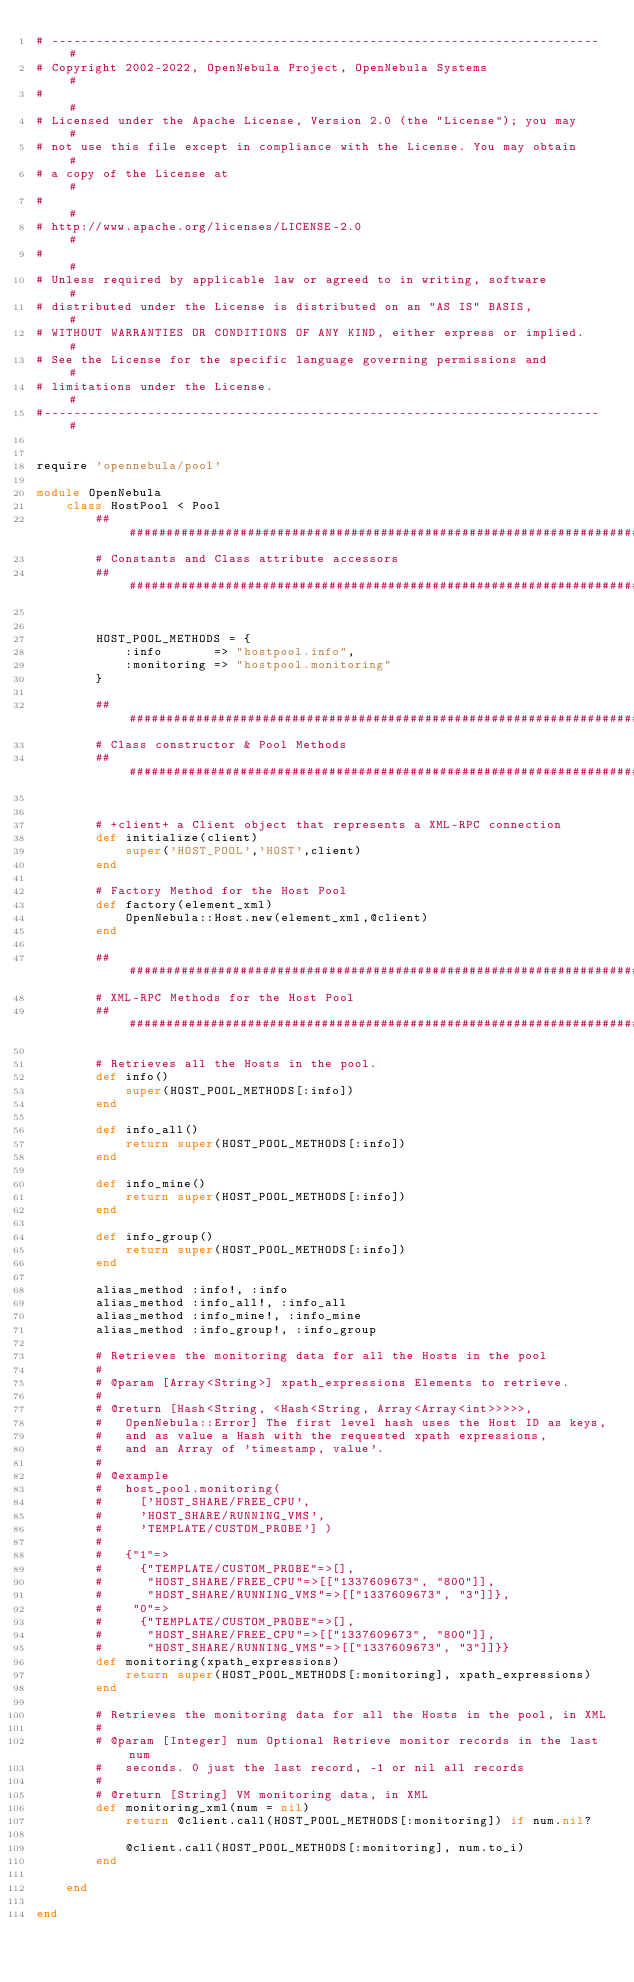Convert code to text. <code><loc_0><loc_0><loc_500><loc_500><_Ruby_># -------------------------------------------------------------------------- #
# Copyright 2002-2022, OpenNebula Project, OpenNebula Systems                #
#                                                                            #
# Licensed under the Apache License, Version 2.0 (the "License"); you may    #
# not use this file except in compliance with the License. You may obtain    #
# a copy of the License at                                                   #
#                                                                            #
# http://www.apache.org/licenses/LICENSE-2.0                                 #
#                                                                            #
# Unless required by applicable law or agreed to in writing, software        #
# distributed under the License is distributed on an "AS IS" BASIS,          #
# WITHOUT WARRANTIES OR CONDITIONS OF ANY KIND, either express or implied.   #
# See the License for the specific language governing permissions and        #
# limitations under the License.                                             #
#--------------------------------------------------------------------------- #


require 'opennebula/pool'

module OpenNebula
    class HostPool < Pool
        #######################################################################
        # Constants and Class attribute accessors
        #######################################################################


        HOST_POOL_METHODS = {
            :info       => "hostpool.info",
            :monitoring => "hostpool.monitoring"
        }

        #######################################################################
        # Class constructor & Pool Methods
        #######################################################################


        # +client+ a Client object that represents a XML-RPC connection
        def initialize(client)
            super('HOST_POOL','HOST',client)
        end

        # Factory Method for the Host Pool
        def factory(element_xml)
            OpenNebula::Host.new(element_xml,@client)
        end

        #######################################################################
        # XML-RPC Methods for the Host Pool
        #######################################################################

        # Retrieves all the Hosts in the pool.
        def info()
            super(HOST_POOL_METHODS[:info])
        end

        def info_all()
            return super(HOST_POOL_METHODS[:info])
        end

        def info_mine()
            return super(HOST_POOL_METHODS[:info])
        end

        def info_group()
            return super(HOST_POOL_METHODS[:info])
        end

        alias_method :info!, :info
        alias_method :info_all!, :info_all
        alias_method :info_mine!, :info_mine
        alias_method :info_group!, :info_group

        # Retrieves the monitoring data for all the Hosts in the pool
        #
        # @param [Array<String>] xpath_expressions Elements to retrieve.
        #
        # @return [Hash<String, <Hash<String, Array<Array<int>>>>>,
        #   OpenNebula::Error] The first level hash uses the Host ID as keys,
        #   and as value a Hash with the requested xpath expressions,
        #   and an Array of 'timestamp, value'.
        #
        # @example
        #   host_pool.monitoring(
        #     ['HOST_SHARE/FREE_CPU',
        #     'HOST_SHARE/RUNNING_VMS',
        #     'TEMPLATE/CUSTOM_PROBE'] )
        #
        #   {"1"=>
        #     {"TEMPLATE/CUSTOM_PROBE"=>[],
        #      "HOST_SHARE/FREE_CPU"=>[["1337609673", "800"]],
        #      "HOST_SHARE/RUNNING_VMS"=>[["1337609673", "3"]]},
        #    "0"=>
        #     {"TEMPLATE/CUSTOM_PROBE"=>[],
        #      "HOST_SHARE/FREE_CPU"=>[["1337609673", "800"]],
        #      "HOST_SHARE/RUNNING_VMS"=>[["1337609673", "3"]]}}
        def monitoring(xpath_expressions)
            return super(HOST_POOL_METHODS[:monitoring], xpath_expressions)
        end

        # Retrieves the monitoring data for all the Hosts in the pool, in XML
        #
        # @param [Integer] num Optional Retrieve monitor records in the last num
        #   seconds. 0 just the last record, -1 or nil all records
        #
        # @return [String] VM monitoring data, in XML
        def monitoring_xml(num = nil)
            return @client.call(HOST_POOL_METHODS[:monitoring]) if num.nil?

            @client.call(HOST_POOL_METHODS[:monitoring], num.to_i)
        end

    end

end
</code> 